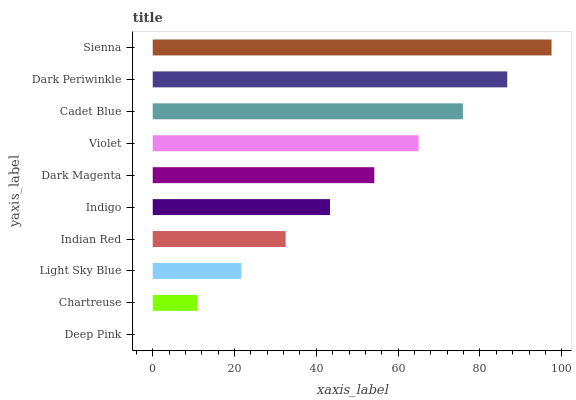Is Deep Pink the minimum?
Answer yes or no. Yes. Is Sienna the maximum?
Answer yes or no. Yes. Is Chartreuse the minimum?
Answer yes or no. No. Is Chartreuse the maximum?
Answer yes or no. No. Is Chartreuse greater than Deep Pink?
Answer yes or no. Yes. Is Deep Pink less than Chartreuse?
Answer yes or no. Yes. Is Deep Pink greater than Chartreuse?
Answer yes or no. No. Is Chartreuse less than Deep Pink?
Answer yes or no. No. Is Dark Magenta the high median?
Answer yes or no. Yes. Is Indigo the low median?
Answer yes or no. Yes. Is Dark Periwinkle the high median?
Answer yes or no. No. Is Dark Magenta the low median?
Answer yes or no. No. 